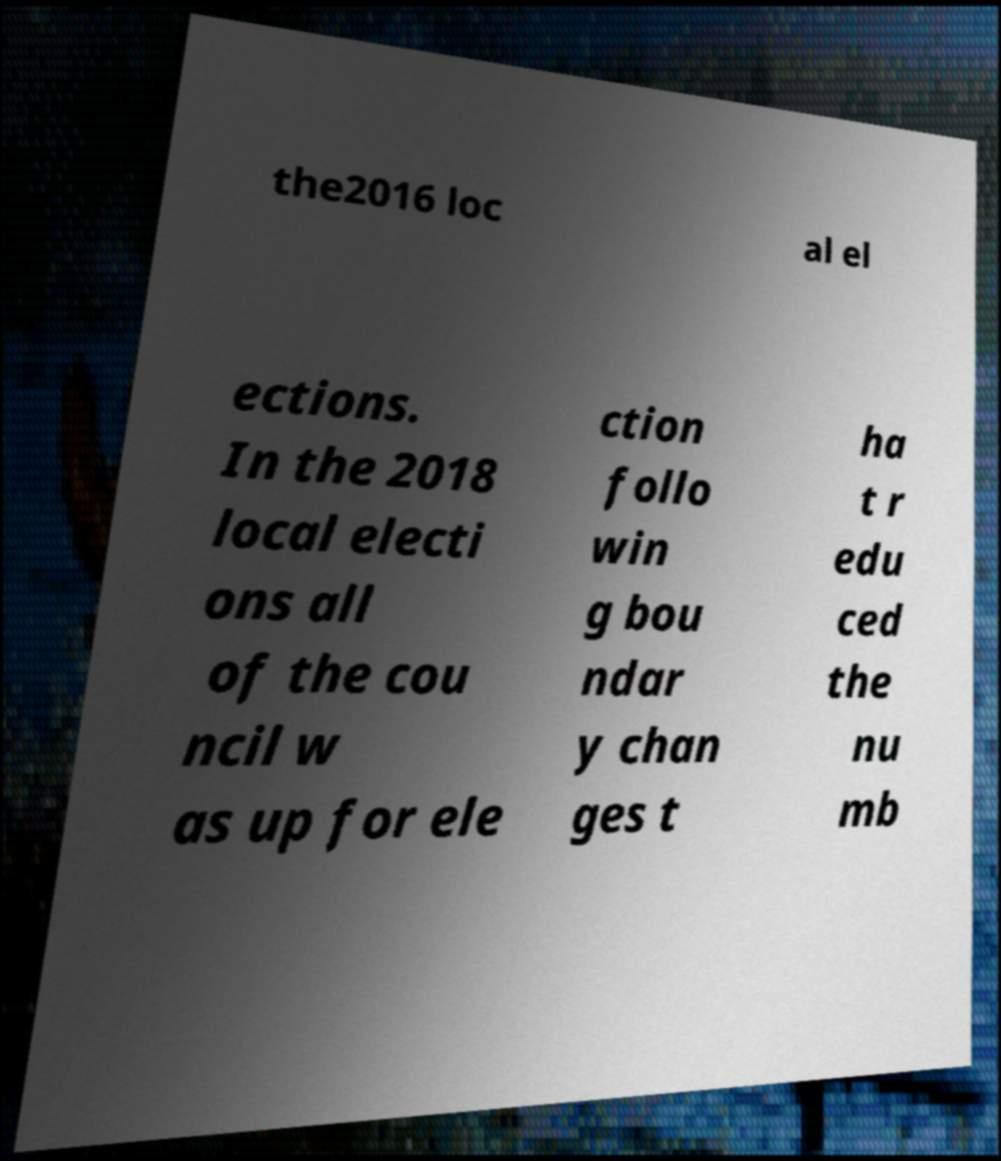Please identify and transcribe the text found in this image. the2016 loc al el ections. In the 2018 local electi ons all of the cou ncil w as up for ele ction follo win g bou ndar y chan ges t ha t r edu ced the nu mb 